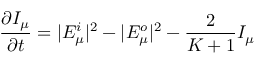<formula> <loc_0><loc_0><loc_500><loc_500>\frac { \partial I _ { \mu } } { \partial t } = | E _ { \mu } ^ { i } | ^ { 2 } - | E _ { \mu } ^ { o } | ^ { 2 } - \frac { 2 } { K + 1 } I _ { \mu }</formula> 